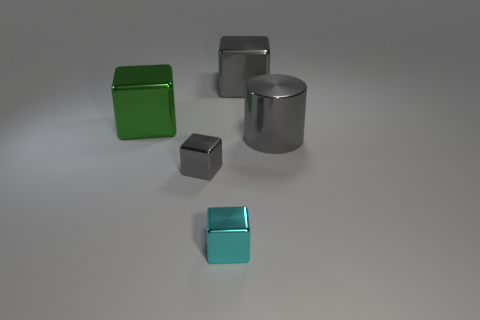Add 5 gray shiny blocks. How many objects exist? 10 Subtract all cylinders. How many objects are left? 4 Add 5 big green cubes. How many big green cubes exist? 6 Subtract 0 brown cubes. How many objects are left? 5 Subtract all large red matte cylinders. Subtract all gray cylinders. How many objects are left? 4 Add 3 small objects. How many small objects are left? 5 